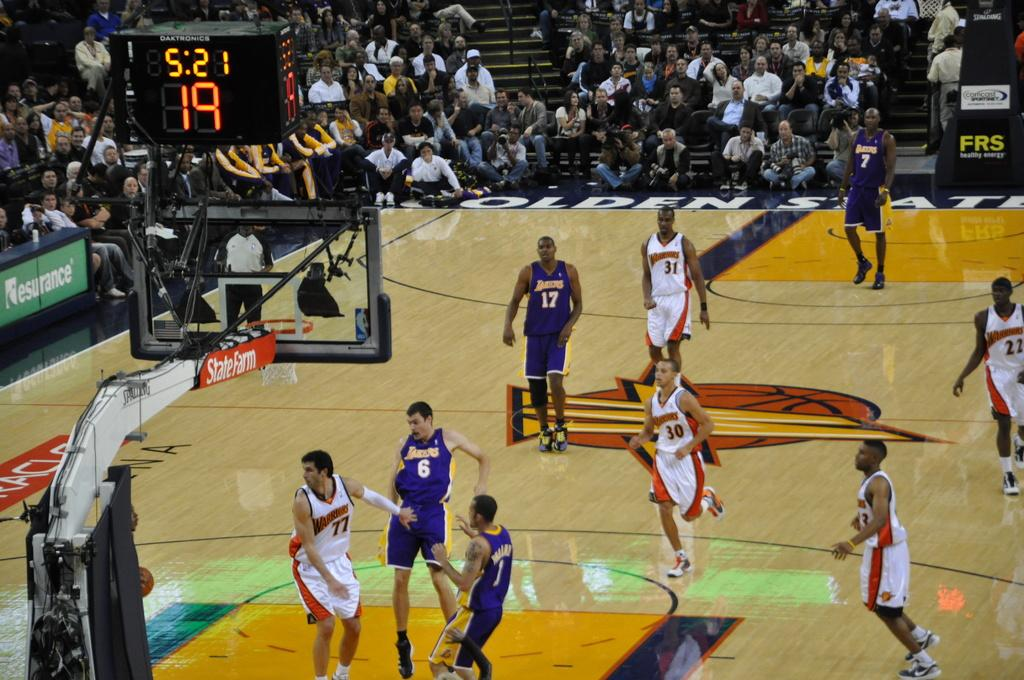<image>
Present a compact description of the photo's key features. A basketball game is going at and the basketball hoop says State Farm. 